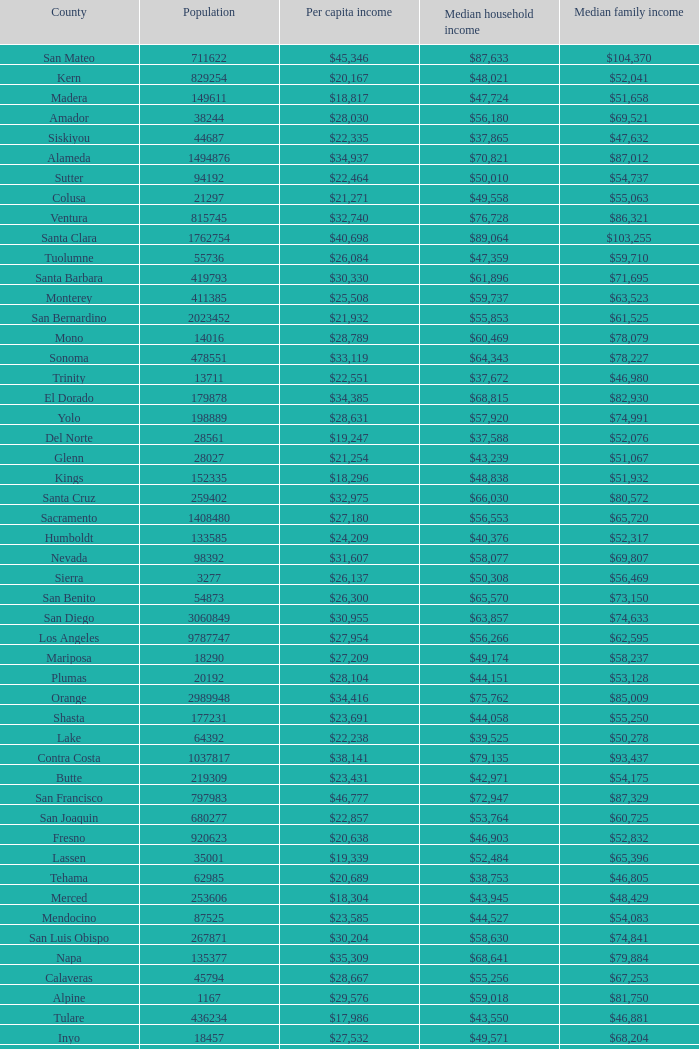What is the median household income of sacramento? $56,553. 